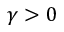<formula> <loc_0><loc_0><loc_500><loc_500>\gamma > 0</formula> 